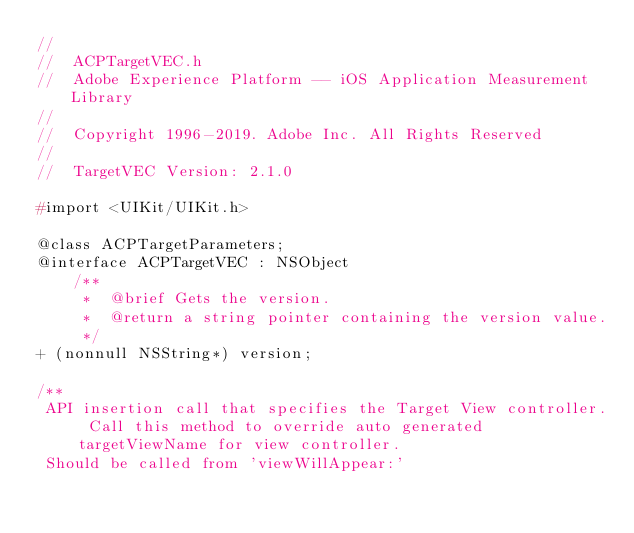<code> <loc_0><loc_0><loc_500><loc_500><_C_>//
//  ACPTargetVEC.h
//  Adobe Experience Platform -- iOS Application Measurement Library
//
//  Copyright 1996-2019. Adobe Inc. All Rights Reserved
//
//  TargetVEC Version: 2.1.0

#import <UIKit/UIKit.h>

@class ACPTargetParameters;
@interface ACPTargetVEC : NSObject
    /**
     *  @brief Gets the version.
     *  @return a string pointer containing the version value.
     */
+ (nonnull NSString*) version;

/**
 API insertion call that specifies the Target View controller. Call this method to override auto generated targetViewName for view controller.
 Should be called from 'viewWillAppear:'
</code> 